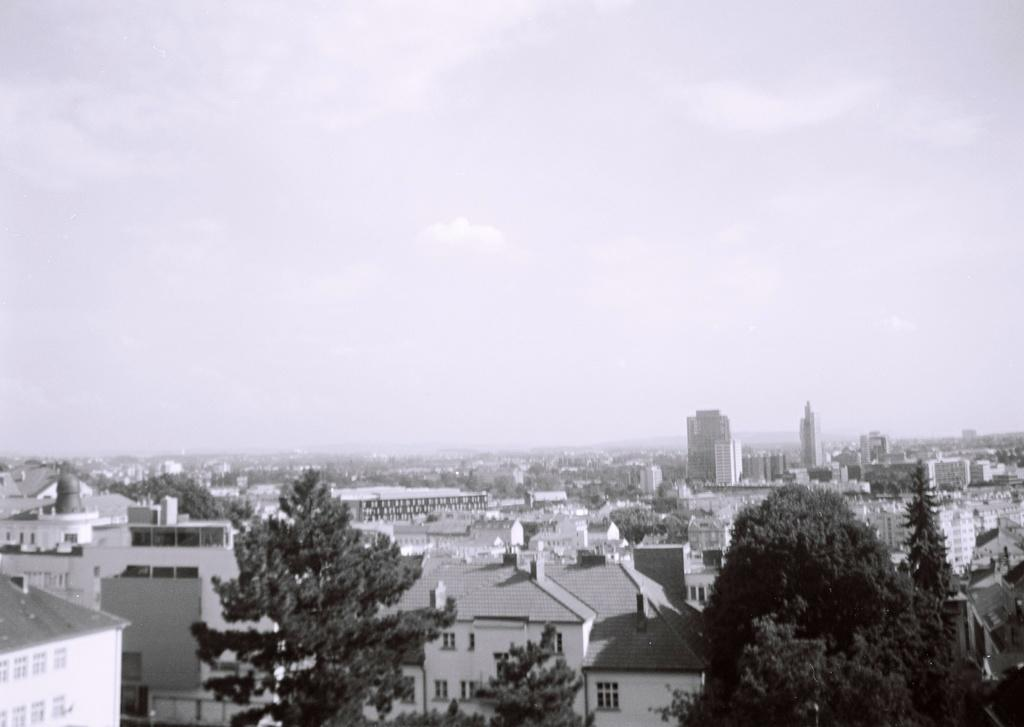What type of location is shown in the image? The image depicts a city. What structures can be seen in the city? There are buildings in the image. Are there any natural elements present in the city? Yes, there are trees in the image. What is visible at the top of the image? The sky is visible at the top of the image. What can be observed in the sky? There are clouds in the sky. Where is the canvas located in the image? There is no canvas present in the image. What type of meeting is taking place in the image? There is no meeting depicted in the image. 